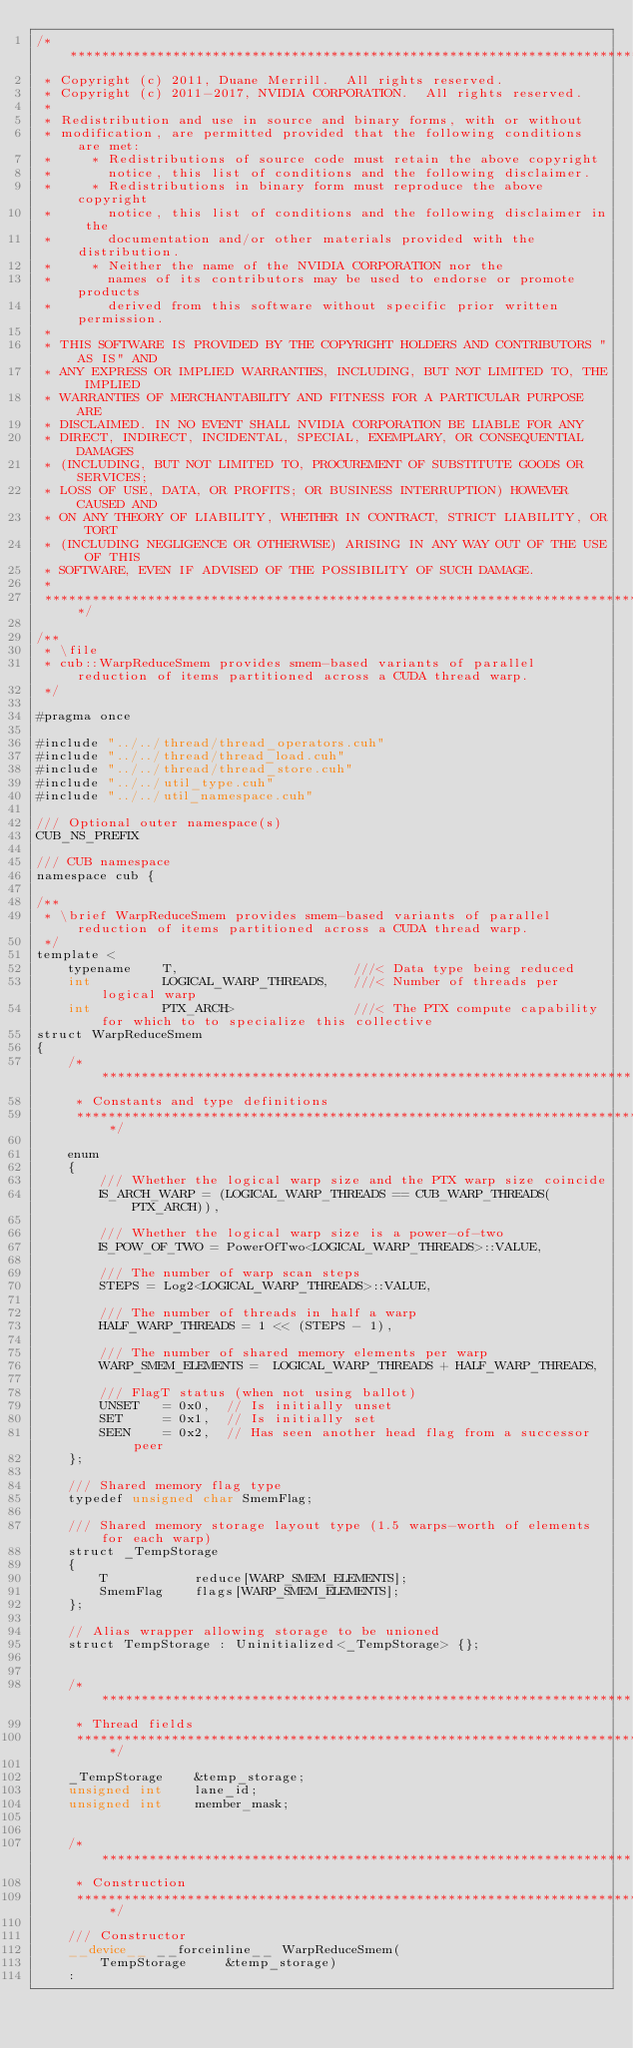Convert code to text. <code><loc_0><loc_0><loc_500><loc_500><_Cuda_>/******************************************************************************
 * Copyright (c) 2011, Duane Merrill.  All rights reserved.
 * Copyright (c) 2011-2017, NVIDIA CORPORATION.  All rights reserved.
 * 
 * Redistribution and use in source and binary forms, with or without
 * modification, are permitted provided that the following conditions are met:
 *     * Redistributions of source code must retain the above copyright
 *       notice, this list of conditions and the following disclaimer.
 *     * Redistributions in binary form must reproduce the above copyright
 *       notice, this list of conditions and the following disclaimer in the
 *       documentation and/or other materials provided with the distribution.
 *     * Neither the name of the NVIDIA CORPORATION nor the
 *       names of its contributors may be used to endorse or promote products
 *       derived from this software without specific prior written permission.
 * 
 * THIS SOFTWARE IS PROVIDED BY THE COPYRIGHT HOLDERS AND CONTRIBUTORS "AS IS" AND
 * ANY EXPRESS OR IMPLIED WARRANTIES, INCLUDING, BUT NOT LIMITED TO, THE IMPLIED
 * WARRANTIES OF MERCHANTABILITY AND FITNESS FOR A PARTICULAR PURPOSE ARE
 * DISCLAIMED. IN NO EVENT SHALL NVIDIA CORPORATION BE LIABLE FOR ANY
 * DIRECT, INDIRECT, INCIDENTAL, SPECIAL, EXEMPLARY, OR CONSEQUENTIAL DAMAGES
 * (INCLUDING, BUT NOT LIMITED TO, PROCUREMENT OF SUBSTITUTE GOODS OR SERVICES;
 * LOSS OF USE, DATA, OR PROFITS; OR BUSINESS INTERRUPTION) HOWEVER CAUSED AND
 * ON ANY THEORY OF LIABILITY, WHETHER IN CONTRACT, STRICT LIABILITY, OR TORT
 * (INCLUDING NEGLIGENCE OR OTHERWISE) ARISING IN ANY WAY OUT OF THE USE OF THIS
 * SOFTWARE, EVEN IF ADVISED OF THE POSSIBILITY OF SUCH DAMAGE.
 *
 ******************************************************************************/

/**
 * \file
 * cub::WarpReduceSmem provides smem-based variants of parallel reduction of items partitioned across a CUDA thread warp.
 */

#pragma once

#include "../../thread/thread_operators.cuh"
#include "../../thread/thread_load.cuh"
#include "../../thread/thread_store.cuh"
#include "../../util_type.cuh"
#include "../../util_namespace.cuh"

/// Optional outer namespace(s)
CUB_NS_PREFIX

/// CUB namespace
namespace cub {

/**
 * \brief WarpReduceSmem provides smem-based variants of parallel reduction of items partitioned across a CUDA thread warp.
 */
template <
    typename    T,                      ///< Data type being reduced
    int         LOGICAL_WARP_THREADS,   ///< Number of threads per logical warp
    int         PTX_ARCH>               ///< The PTX compute capability for which to to specialize this collective
struct WarpReduceSmem
{
    /******************************************************************************
     * Constants and type definitions
     ******************************************************************************/

    enum
    {
        /// Whether the logical warp size and the PTX warp size coincide
        IS_ARCH_WARP = (LOGICAL_WARP_THREADS == CUB_WARP_THREADS(PTX_ARCH)),

        /// Whether the logical warp size is a power-of-two
        IS_POW_OF_TWO = PowerOfTwo<LOGICAL_WARP_THREADS>::VALUE,

        /// The number of warp scan steps
        STEPS = Log2<LOGICAL_WARP_THREADS>::VALUE,

        /// The number of threads in half a warp
        HALF_WARP_THREADS = 1 << (STEPS - 1),

        /// The number of shared memory elements per warp
        WARP_SMEM_ELEMENTS =  LOGICAL_WARP_THREADS + HALF_WARP_THREADS,

        /// FlagT status (when not using ballot)
        UNSET   = 0x0,  // Is initially unset
        SET     = 0x1,  // Is initially set
        SEEN    = 0x2,  // Has seen another head flag from a successor peer
    };

    /// Shared memory flag type
    typedef unsigned char SmemFlag;

    /// Shared memory storage layout type (1.5 warps-worth of elements for each warp)
    struct _TempStorage
    {
        T           reduce[WARP_SMEM_ELEMENTS];
        SmemFlag    flags[WARP_SMEM_ELEMENTS];
    };

    // Alias wrapper allowing storage to be unioned
    struct TempStorage : Uninitialized<_TempStorage> {};


    /******************************************************************************
     * Thread fields
     ******************************************************************************/

    _TempStorage    &temp_storage;
    unsigned int    lane_id;
    unsigned int    member_mask;


    /******************************************************************************
     * Construction
     ******************************************************************************/

    /// Constructor
    __device__ __forceinline__ WarpReduceSmem(
        TempStorage     &temp_storage)
    :</code> 